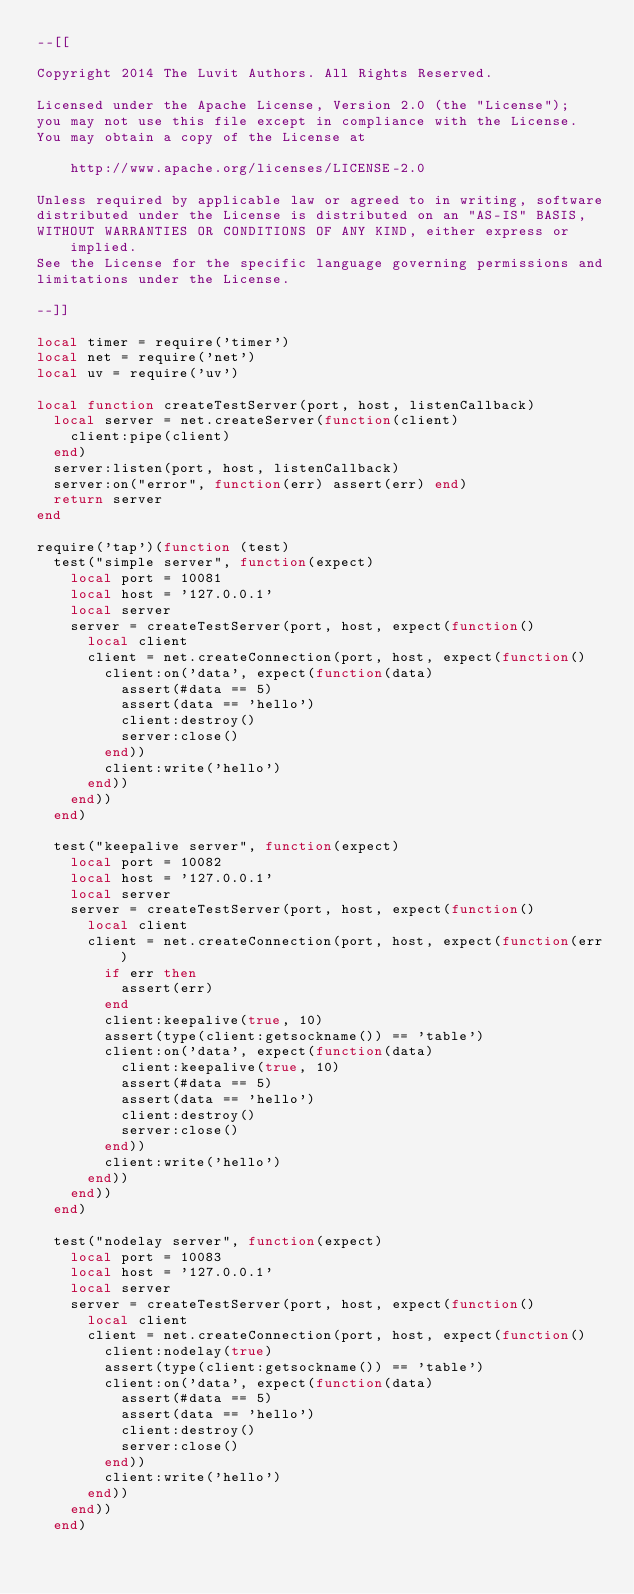Convert code to text. <code><loc_0><loc_0><loc_500><loc_500><_Lua_>--[[

Copyright 2014 The Luvit Authors. All Rights Reserved.

Licensed under the Apache License, Version 2.0 (the "License");
you may not use this file except in compliance with the License.
You may obtain a copy of the License at

    http://www.apache.org/licenses/LICENSE-2.0

Unless required by applicable law or agreed to in writing, software
distributed under the License is distributed on an "AS-IS" BASIS,
WITHOUT WARRANTIES OR CONDITIONS OF ANY KIND, either express or implied.
See the License for the specific language governing permissions and
limitations under the License.

--]]

local timer = require('timer')
local net = require('net')
local uv = require('uv')

local function createTestServer(port, host, listenCallback)
  local server = net.createServer(function(client)
    client:pipe(client)
  end)
  server:listen(port, host, listenCallback)
  server:on("error", function(err) assert(err) end)
  return server
end

require('tap')(function (test)
  test("simple server", function(expect)
    local port = 10081
    local host = '127.0.0.1'
    local server
    server = createTestServer(port, host, expect(function()
      local client
      client = net.createConnection(port, host, expect(function()
        client:on('data', expect(function(data)
          assert(#data == 5)
          assert(data == 'hello')
          client:destroy()
          server:close()
        end))
        client:write('hello')
      end))
    end))
  end)

  test("keepalive server", function(expect)
    local port = 10082
    local host = '127.0.0.1'
    local server
    server = createTestServer(port, host, expect(function()
      local client
      client = net.createConnection(port, host, expect(function(err)
        if err then
          assert(err)
        end
        client:keepalive(true, 10)
        assert(type(client:getsockname()) == 'table')
        client:on('data', expect(function(data)
          client:keepalive(true, 10)
          assert(#data == 5)
          assert(data == 'hello')
          client:destroy()
          server:close()
        end))
        client:write('hello')
      end))
    end))
  end)

  test("nodelay server", function(expect)
    local port = 10083
    local host = '127.0.0.1'
    local server
    server = createTestServer(port, host, expect(function()
      local client
      client = net.createConnection(port, host, expect(function()
        client:nodelay(true)
        assert(type(client:getsockname()) == 'table')
        client:on('data', expect(function(data)
          assert(#data == 5)
          assert(data == 'hello')
          client:destroy()
          server:close()
        end))
        client:write('hello')
      end))
    end))
  end)
</code> 